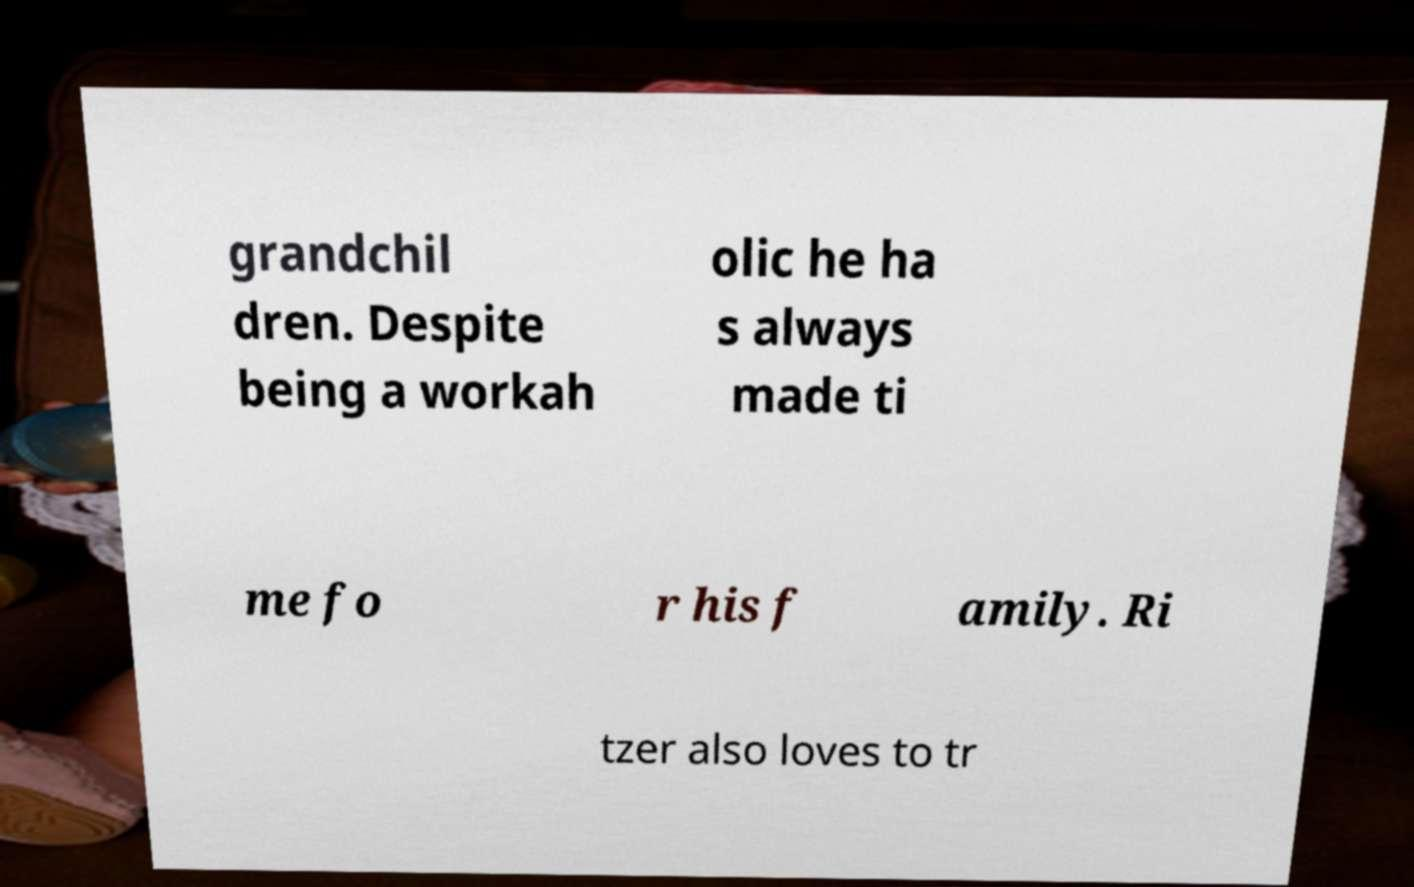I need the written content from this picture converted into text. Can you do that? grandchil dren. Despite being a workah olic he ha s always made ti me fo r his f amily. Ri tzer also loves to tr 